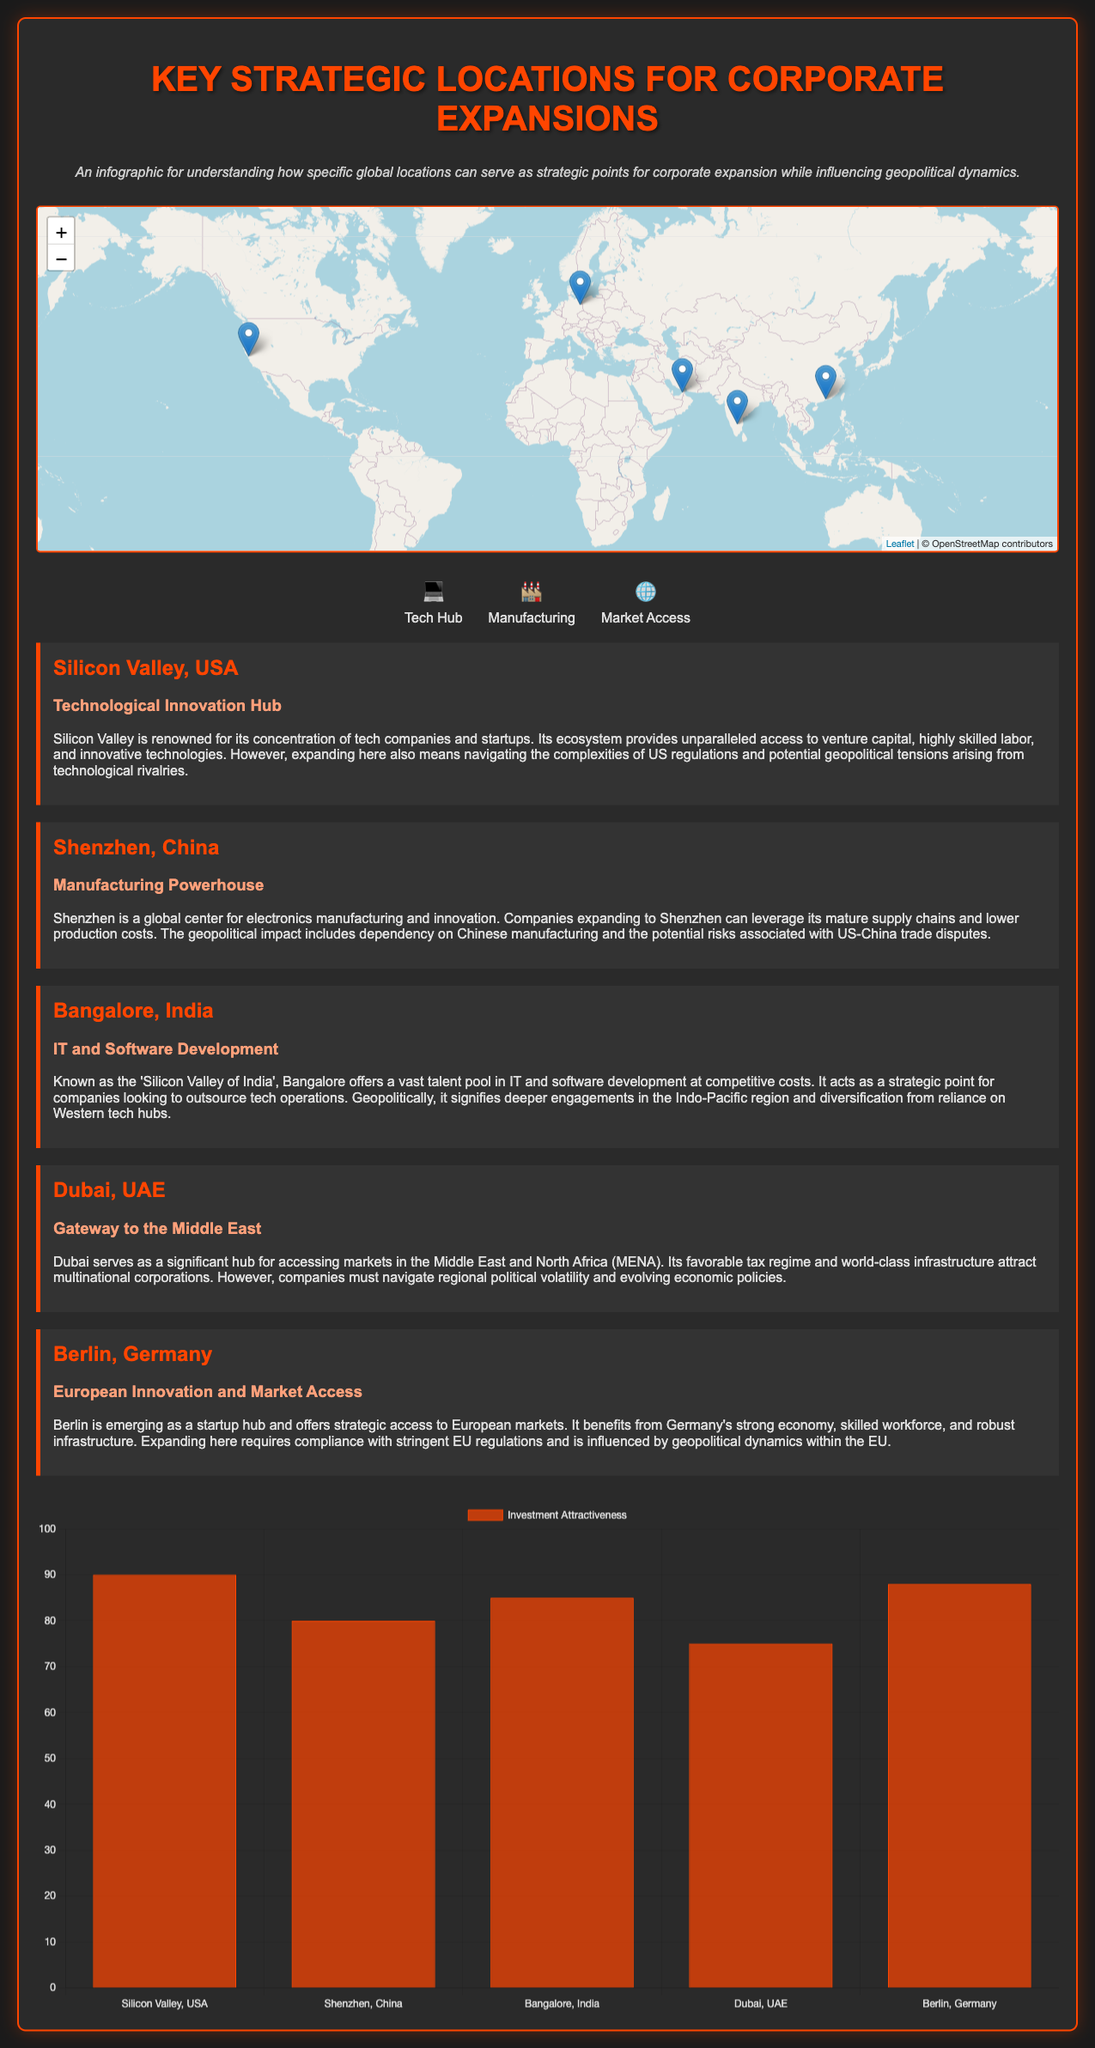What is the title of the infographic? The title of the infographic is stated at the top of the document.
Answer: Key Strategic Locations for Corporate Expansions What is the investment attractiveness score for Silicon Valley? The investment attractiveness scores are shown in the data chart, with Silicon Valley having a score of 90.
Answer: 90 Which location is referred to as the 'Silicon Valley of India'? The document explicitly mentions Bangalore as the 'Silicon Valley of India'.
Answer: Bangalore What is the primary industry in Shenzhen? The document describes Shenzhen as a manufacturing powerhouse, indicating its primary industry.
Answer: Manufacturing What color represents the Tech Hub icon in the legend? The color of the icon legend is observed; the Tech Hub icon is associated with a computer emoji.
Answer: 💻 Where does Dubai serve as a gateway to? The document specifies that Dubai serves as a gateway to the Middle East and North Africa (MENA).
Answer: Middle East and North Africa What is the geopolitical risk associated with expanding to Shenzhen? The document states that the geopolitical risk includes potential risks associated with US-China trade disputes.
Answer: US-China trade disputes Which city has strong access to European markets according to the document? Berlin is mentioned as providing strategic access to European markets in the document.
Answer: Berlin What is the main advantage of expanding in Bangalore? The main advantage listed for Bangalore is its vast talent pool in IT and software development.
Answer: Talent pool in IT and software development 